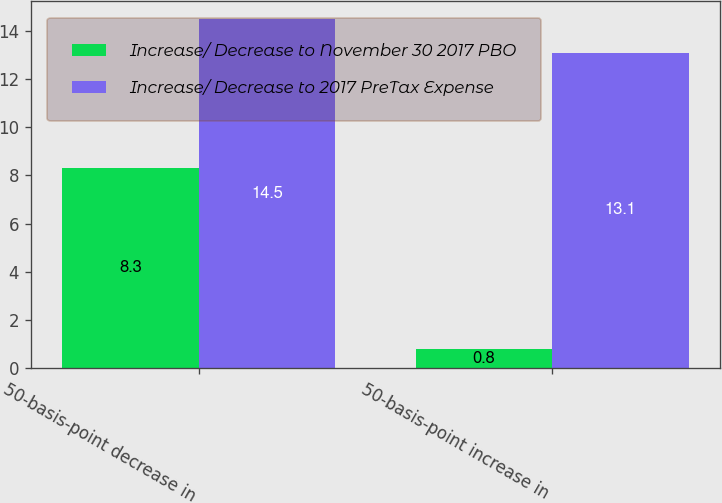Convert chart. <chart><loc_0><loc_0><loc_500><loc_500><stacked_bar_chart><ecel><fcel>50-basis-point decrease in<fcel>50-basis-point increase in<nl><fcel>Increase/ Decrease to November 30 2017 PBO<fcel>8.3<fcel>0.8<nl><fcel>Increase/ Decrease to 2017 PreTax Expense<fcel>14.5<fcel>13.1<nl></chart> 